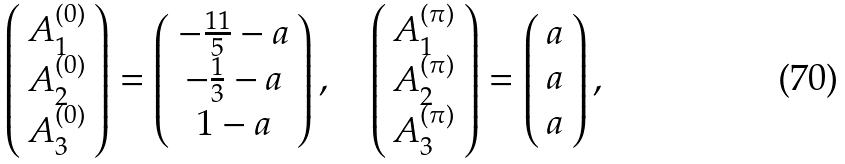<formula> <loc_0><loc_0><loc_500><loc_500>\left ( \begin{array} { c } A _ { 1 } ^ { ( 0 ) } \\ A _ { 2 } ^ { ( 0 ) } \\ A _ { 3 } ^ { ( 0 ) } \end{array} \right ) = \left ( \begin{array} { c } - \frac { 1 1 } { 5 } - a \\ - \frac { 1 } { 3 } - a \\ 1 - a \end{array} \right ) , \quad \left ( \begin{array} { c } A _ { 1 } ^ { ( \pi ) } \\ A _ { 2 } ^ { ( \pi ) } \\ A _ { 3 } ^ { ( \pi ) } \end{array} \right ) = \left ( \begin{array} { c } a \\ a \\ a \end{array} \right ) ,</formula> 